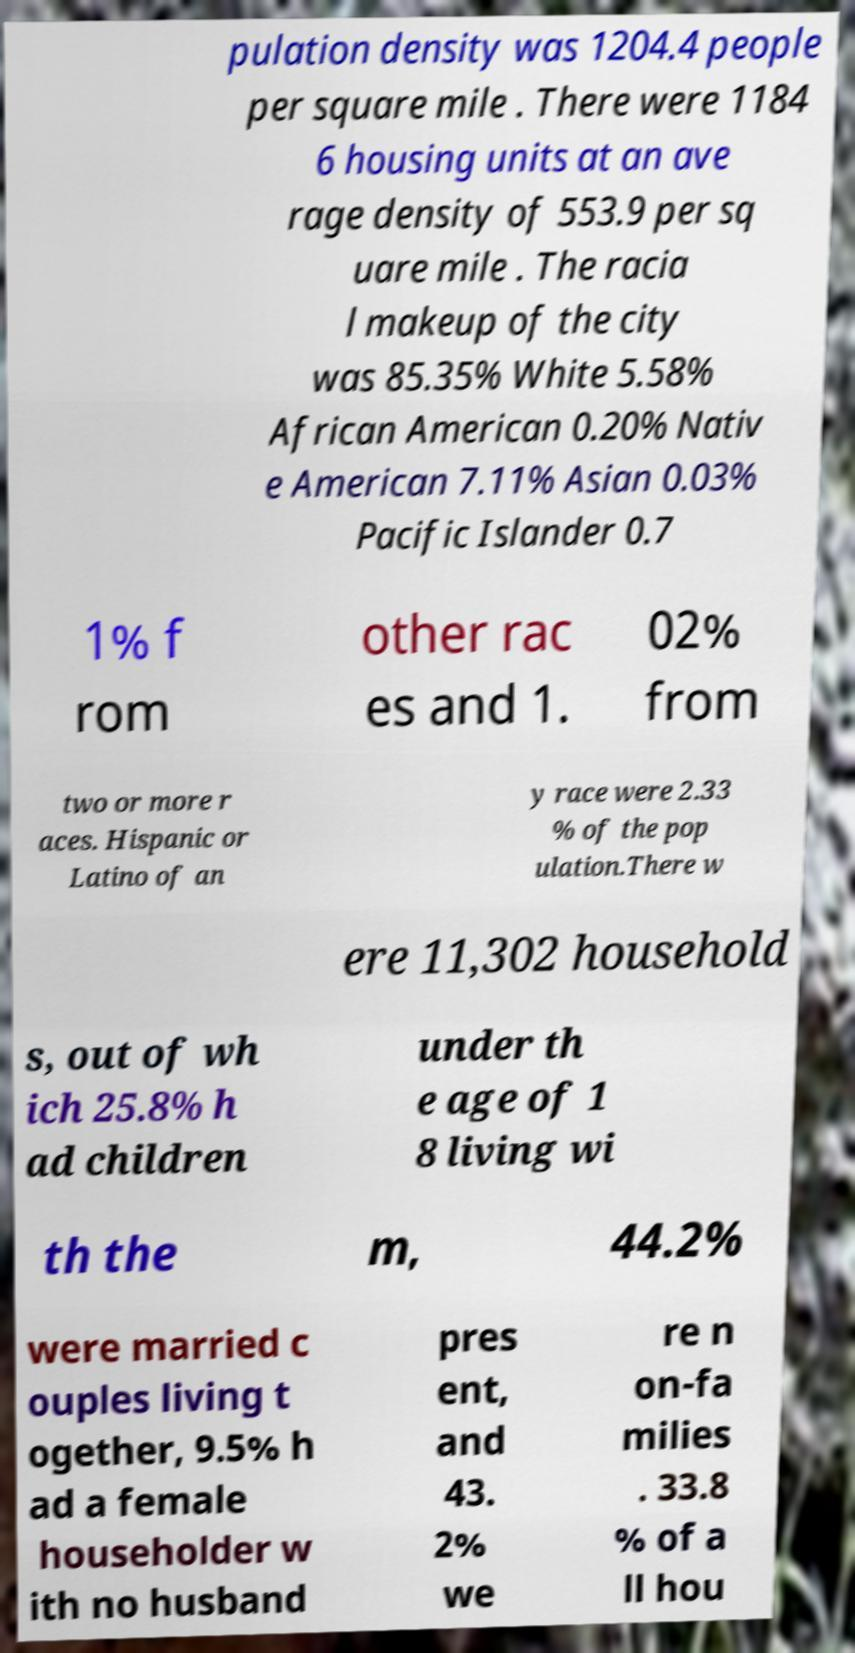What messages or text are displayed in this image? I need them in a readable, typed format. pulation density was 1204.4 people per square mile . There were 1184 6 housing units at an ave rage density of 553.9 per sq uare mile . The racia l makeup of the city was 85.35% White 5.58% African American 0.20% Nativ e American 7.11% Asian 0.03% Pacific Islander 0.7 1% f rom other rac es and 1. 02% from two or more r aces. Hispanic or Latino of an y race were 2.33 % of the pop ulation.There w ere 11,302 household s, out of wh ich 25.8% h ad children under th e age of 1 8 living wi th the m, 44.2% were married c ouples living t ogether, 9.5% h ad a female householder w ith no husband pres ent, and 43. 2% we re n on-fa milies . 33.8 % of a ll hou 